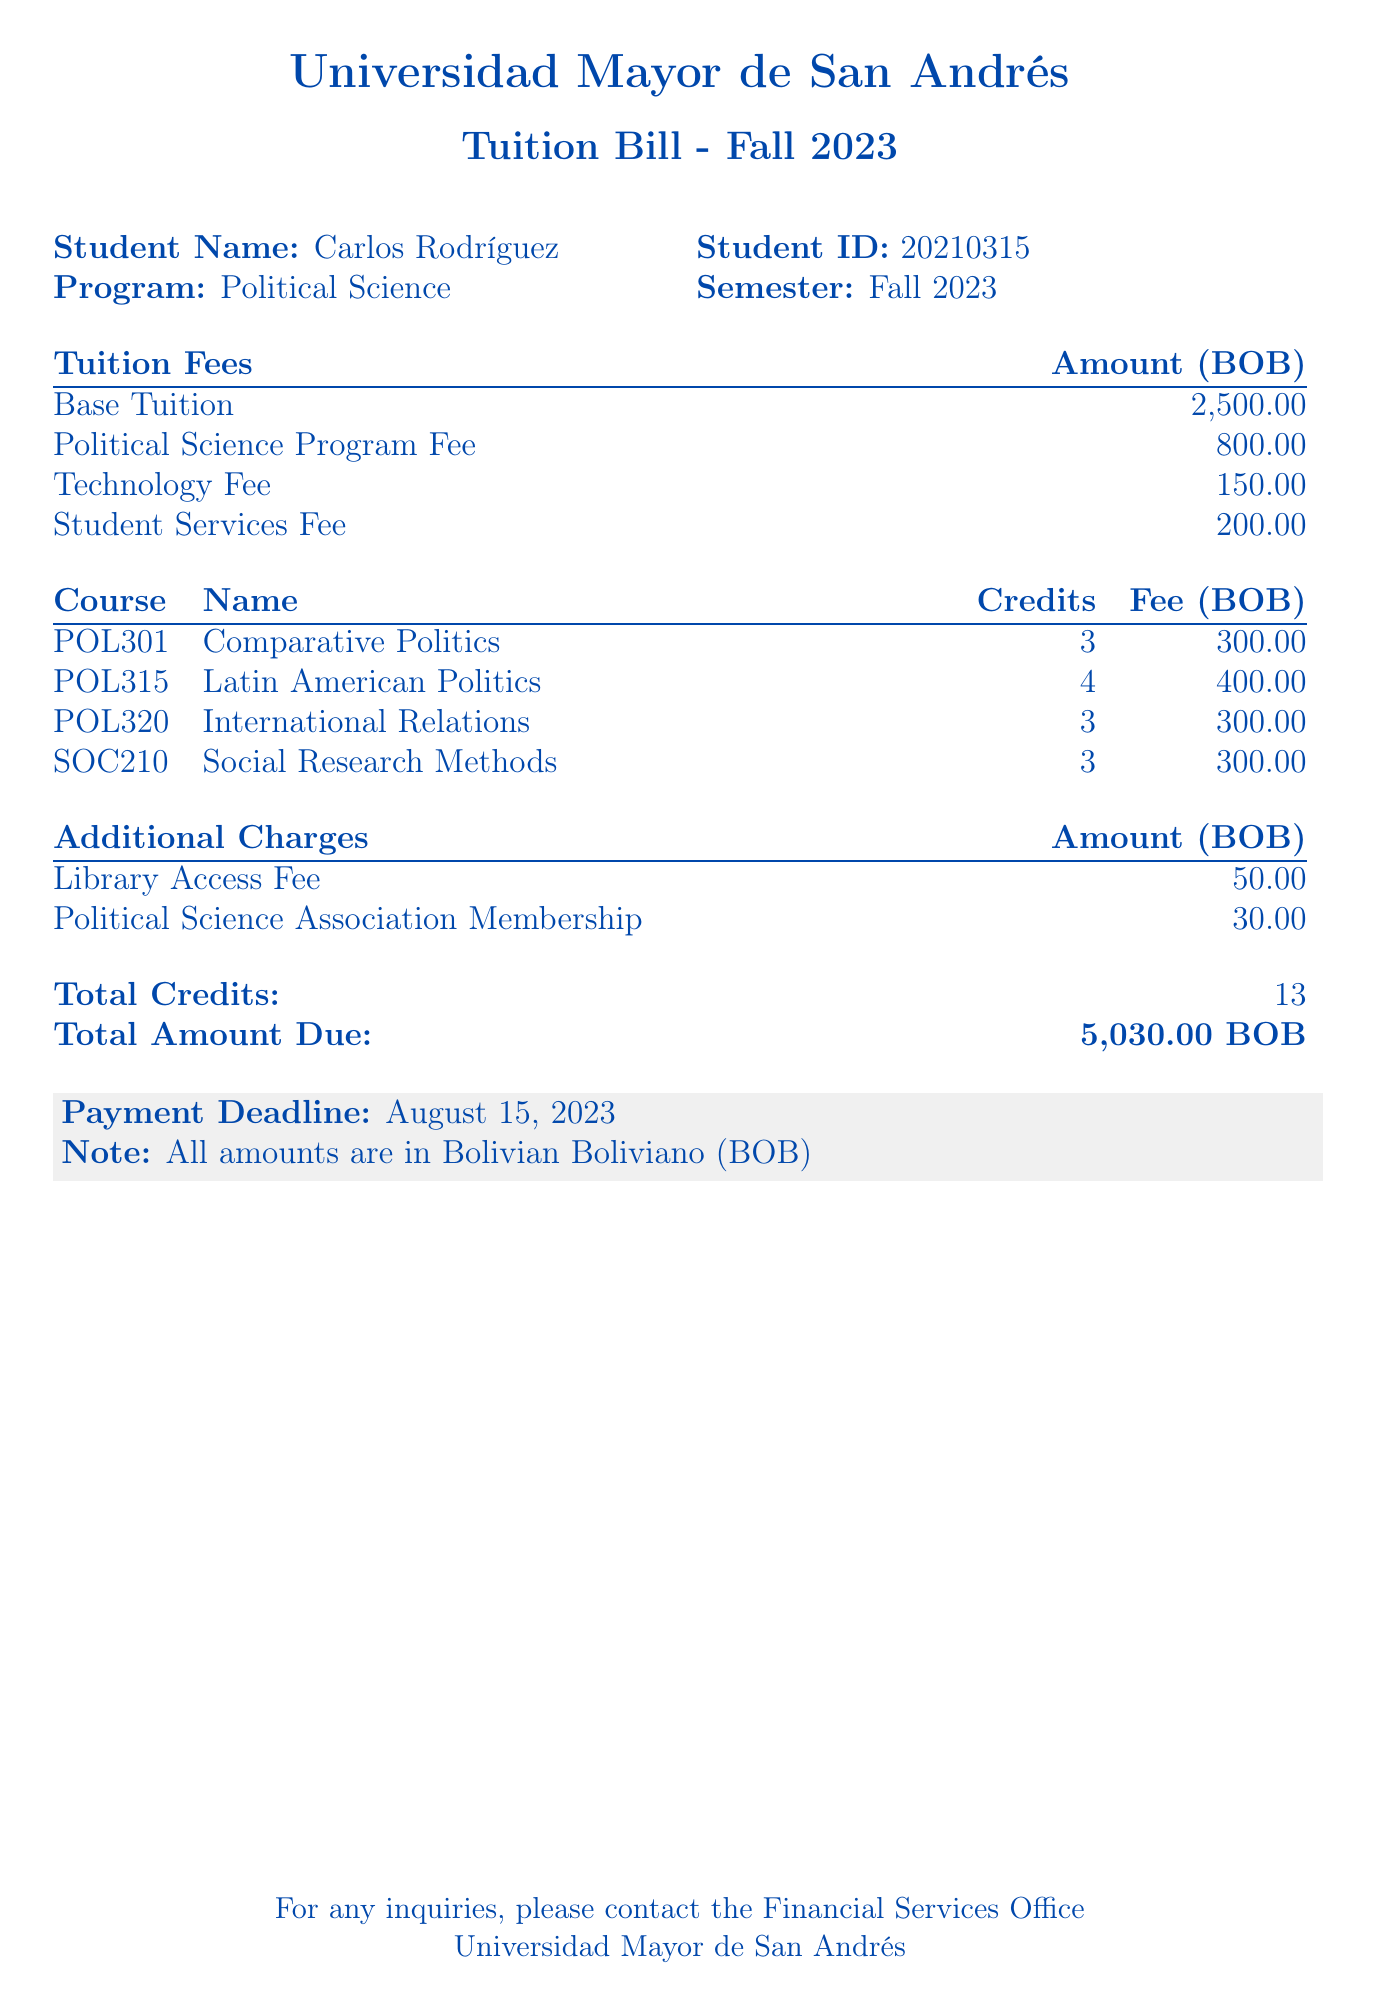What is the total amount due? The total amount due is specified in the document as the final sum of all fees, which is 5,030.00 BOB.
Answer: 5,030.00 BOB What is the technology fee? The technology fee is listed as a separate charge in the tuition fees section of the bill.
Answer: 150.00 How many credits are the courses worth in total? The total credits are already summed up and presented at the bottom of the breakdown of course fees.
Answer: 13 What is the payment deadline? The payment deadline is stated clearly in the footnote section of the bill.
Answer: August 15, 2023 What is the Political Science Program Fee? The Political Science Program Fee is a specific charge for students enrolled in that program and listed in the tuition fees.
Answer: 800.00 How many courses are included in the bill? The number of courses can be counted from the course listing provided in the document.
Answer: 4 What is included in the additional charges? The additional charges section lists specific fees that are not part of the main tuition fees.
Answer: Library Access Fee and Political Science Association Membership What is the student's name? The student's name is displayed prominently at the top section of the bill.
Answer: Carlos Rodríguez What program is the student enrolled in? The program enrollment is mentioned next to the student information at the start of the document.
Answer: Political Science 